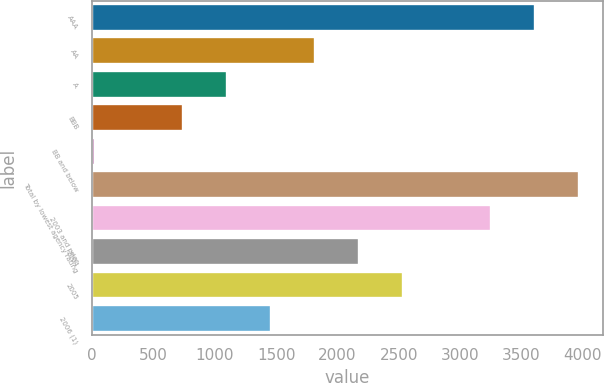Convert chart to OTSL. <chart><loc_0><loc_0><loc_500><loc_500><bar_chart><fcel>AAA<fcel>AA<fcel>A<fcel>BBB<fcel>BB and below<fcel>Total by lowest agency rating<fcel>2003 and prior<fcel>2004<fcel>2005<fcel>2006 (1)<nl><fcel>3607.1<fcel>1816.65<fcel>1100.47<fcel>742.38<fcel>26.2<fcel>3965.19<fcel>3249.01<fcel>2174.74<fcel>2532.83<fcel>1458.56<nl></chart> 